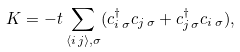Convert formula to latex. <formula><loc_0><loc_0><loc_500><loc_500>K = - t \sum _ { \langle i \, j \rangle , \sigma } ( c ^ { \dagger } _ { i \, \sigma } c _ { j \, \sigma } + c ^ { \dagger } _ { j \, \sigma } c _ { i \, \sigma } ) ,</formula> 